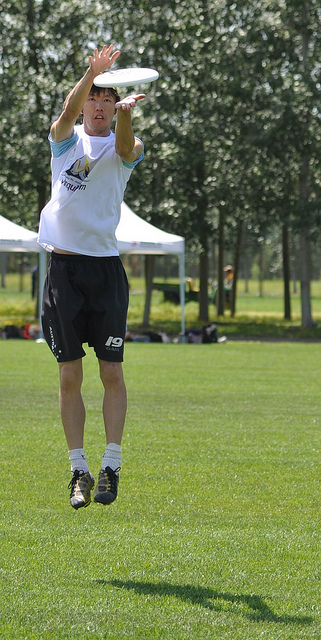Please transcribe the text information in this image. 19 